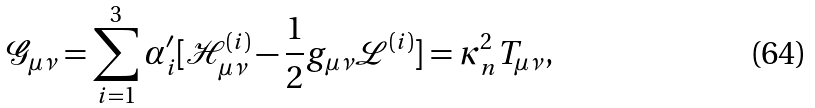Convert formula to latex. <formula><loc_0><loc_0><loc_500><loc_500>\mathcal { G } _ { \mu \nu } = \sum _ { i = 1 } ^ { 3 } \alpha _ { i } ^ { \prime } [ \mathcal { H } _ { \mu \nu } ^ { ( i ) } - \frac { 1 } { 2 } g _ { \mu \nu } \mathcal { L } ^ { ( i ) } ] = \kappa _ { n } ^ { 2 } T _ { \mu \nu } ,</formula> 